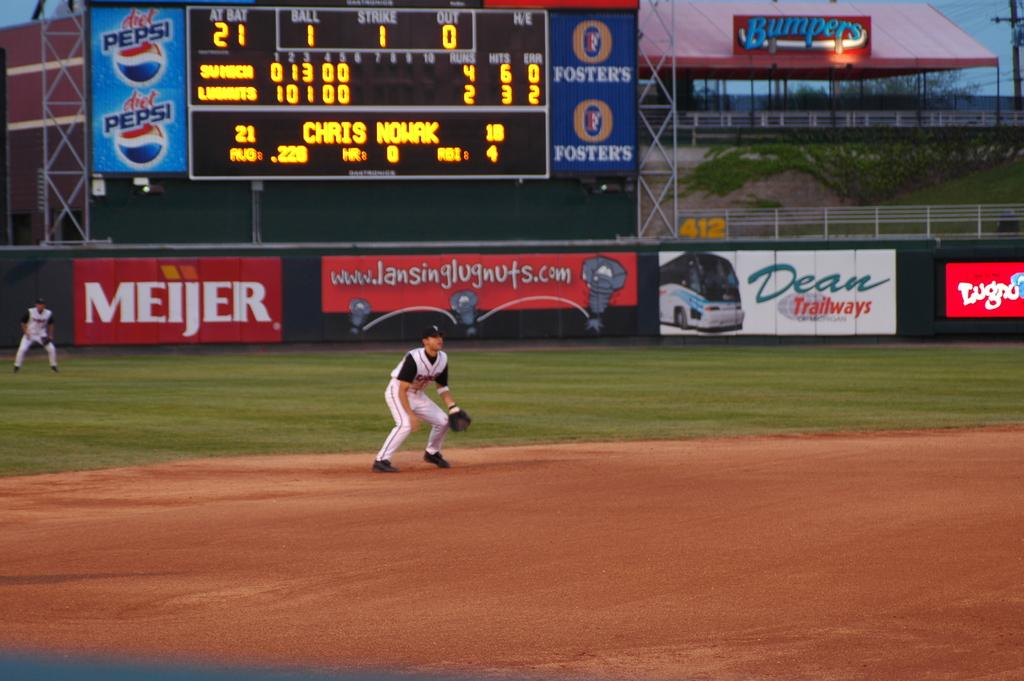<image>
Create a compact narrative representing the image presented. a baseball player with a dean advertisement in the outfield 